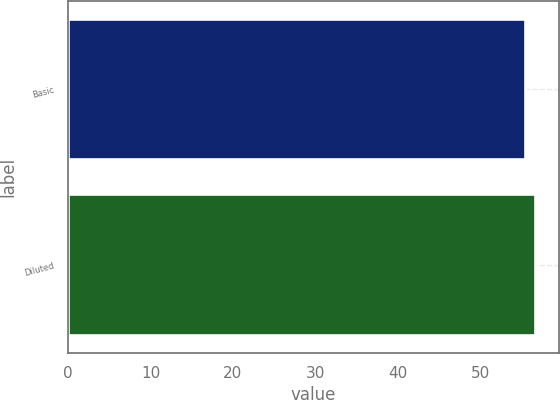Convert chart. <chart><loc_0><loc_0><loc_500><loc_500><bar_chart><fcel>Basic<fcel>Diluted<nl><fcel>55.5<fcel>56.7<nl></chart> 